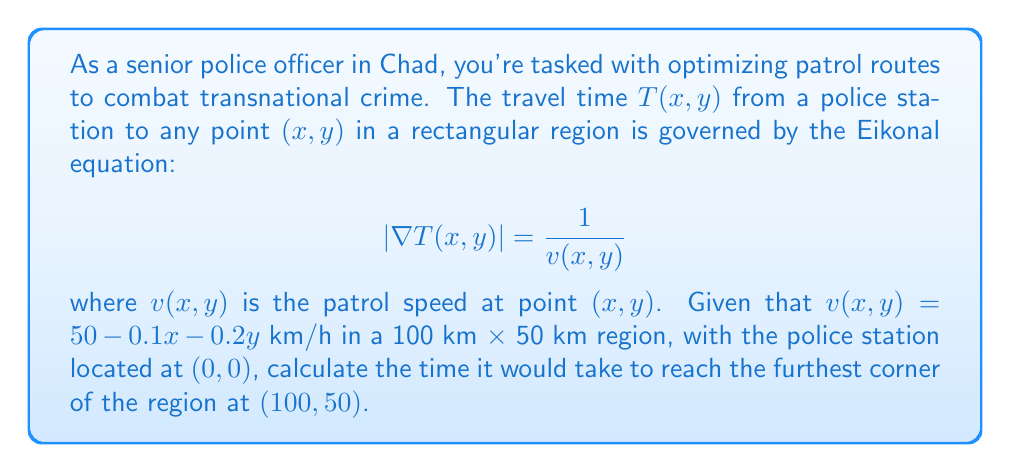Give your solution to this math problem. To solve this problem, we need to integrate the reciprocal of the velocity along the optimal path. The Eikonal equation ensures that we're considering the fastest possible route.

1) First, let's consider the path. The optimal path in this case is a straight line from $(0,0)$ to $(100,50)$, as the velocity function is continuous and monotonically decreasing in both $x$ and $y$.

2) We can parametrize this path as:
   $x(t) = 100t$, $y(t) = 50t$, where $0 \leq t \leq 1$

3) The velocity along this path is:
   $v(t) = 50 - 0.1(100t) - 0.2(50t) = 50 - 10t - 10t = 50 - 20t$

4) The time taken is the integral of $\frac{1}{v}$ along the path:

   $$T = \int_0^1 \frac{\sqrt{(100)^2 + (50)^2}}{50 - 20t} dt = \frac{\sqrt{12500}}{20} \int_0^1 \frac{1}{2.5 - t} dt$$

5) Evaluating this integral:

   $$T = \frac{\sqrt{12500}}{20} [-\ln(2.5-t)]_0^1 = \frac{\sqrt{12500}}{20} [\ln(2.5) - \ln(1.5)]$$

6) Simplifying:

   $$T = \frac{\sqrt{12500}}{20} \ln(\frac{5}{3}) \approx 2.77 \text{ hours}$$
Answer: The time taken to reach the furthest corner of the region is approximately 2.77 hours. 